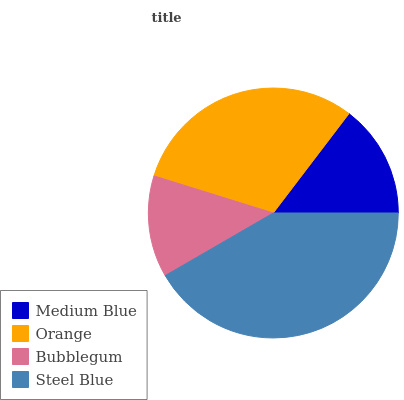Is Bubblegum the minimum?
Answer yes or no. Yes. Is Steel Blue the maximum?
Answer yes or no. Yes. Is Orange the minimum?
Answer yes or no. No. Is Orange the maximum?
Answer yes or no. No. Is Orange greater than Medium Blue?
Answer yes or no. Yes. Is Medium Blue less than Orange?
Answer yes or no. Yes. Is Medium Blue greater than Orange?
Answer yes or no. No. Is Orange less than Medium Blue?
Answer yes or no. No. Is Orange the high median?
Answer yes or no. Yes. Is Medium Blue the low median?
Answer yes or no. Yes. Is Medium Blue the high median?
Answer yes or no. No. Is Steel Blue the low median?
Answer yes or no. No. 